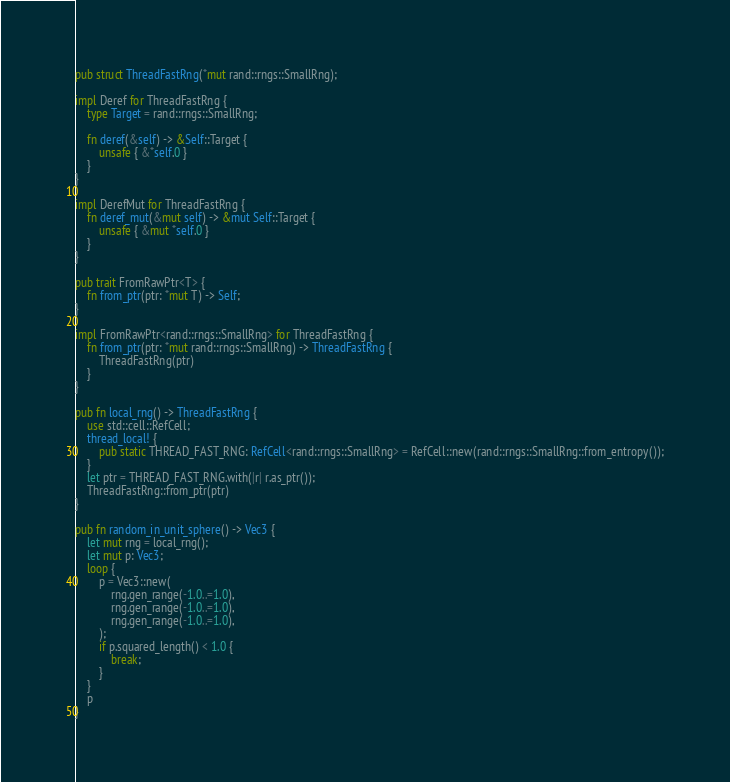Convert code to text. <code><loc_0><loc_0><loc_500><loc_500><_Rust_>pub struct ThreadFastRng(*mut rand::rngs::SmallRng);

impl Deref for ThreadFastRng {
    type Target = rand::rngs::SmallRng;

    fn deref(&self) -> &Self::Target {
        unsafe { &*self.0 }
    }
}

impl DerefMut for ThreadFastRng {
    fn deref_mut(&mut self) -> &mut Self::Target {
        unsafe { &mut *self.0 }
    }
}

pub trait FromRawPtr<T> {
    fn from_ptr(ptr: *mut T) -> Self;
}

impl FromRawPtr<rand::rngs::SmallRng> for ThreadFastRng {
    fn from_ptr(ptr: *mut rand::rngs::SmallRng) -> ThreadFastRng {
        ThreadFastRng(ptr)
    }
}

pub fn local_rng() -> ThreadFastRng {
    use std::cell::RefCell;
    thread_local! {
        pub static THREAD_FAST_RNG: RefCell<rand::rngs::SmallRng> = RefCell::new(rand::rngs::SmallRng::from_entropy());
    }
    let ptr = THREAD_FAST_RNG.with(|r| r.as_ptr());
    ThreadFastRng::from_ptr(ptr)
}

pub fn random_in_unit_sphere() -> Vec3 {
    let mut rng = local_rng();
    let mut p: Vec3;
    loop {
        p = Vec3::new(
            rng.gen_range(-1.0..=1.0),
            rng.gen_range(-1.0..=1.0),
            rng.gen_range(-1.0..=1.0),
        );
        if p.squared_length() < 1.0 {
            break;
        }
    }
    p
}
</code> 